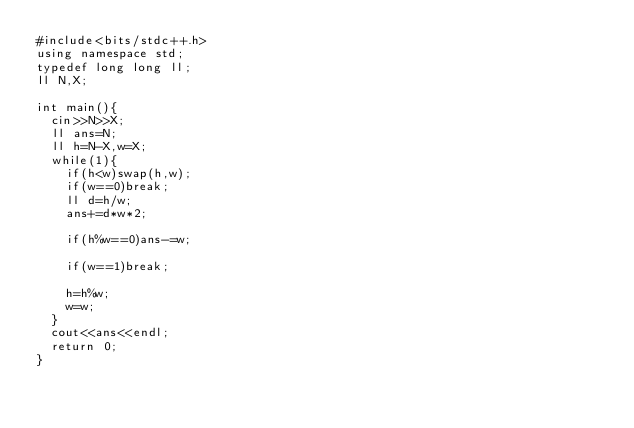Convert code to text. <code><loc_0><loc_0><loc_500><loc_500><_C++_>#include<bits/stdc++.h>
using namespace std;
typedef long long ll;
ll N,X;

int main(){
  cin>>N>>X;
  ll ans=N;
  ll h=N-X,w=X;
  while(1){
    if(h<w)swap(h,w);
    if(w==0)break;
    ll d=h/w;
    ans+=d*w*2;
    
    if(h%w==0)ans-=w;
    
    if(w==1)break;
    
    h=h%w;
    w=w;
  }
  cout<<ans<<endl;
  return 0;
}
</code> 